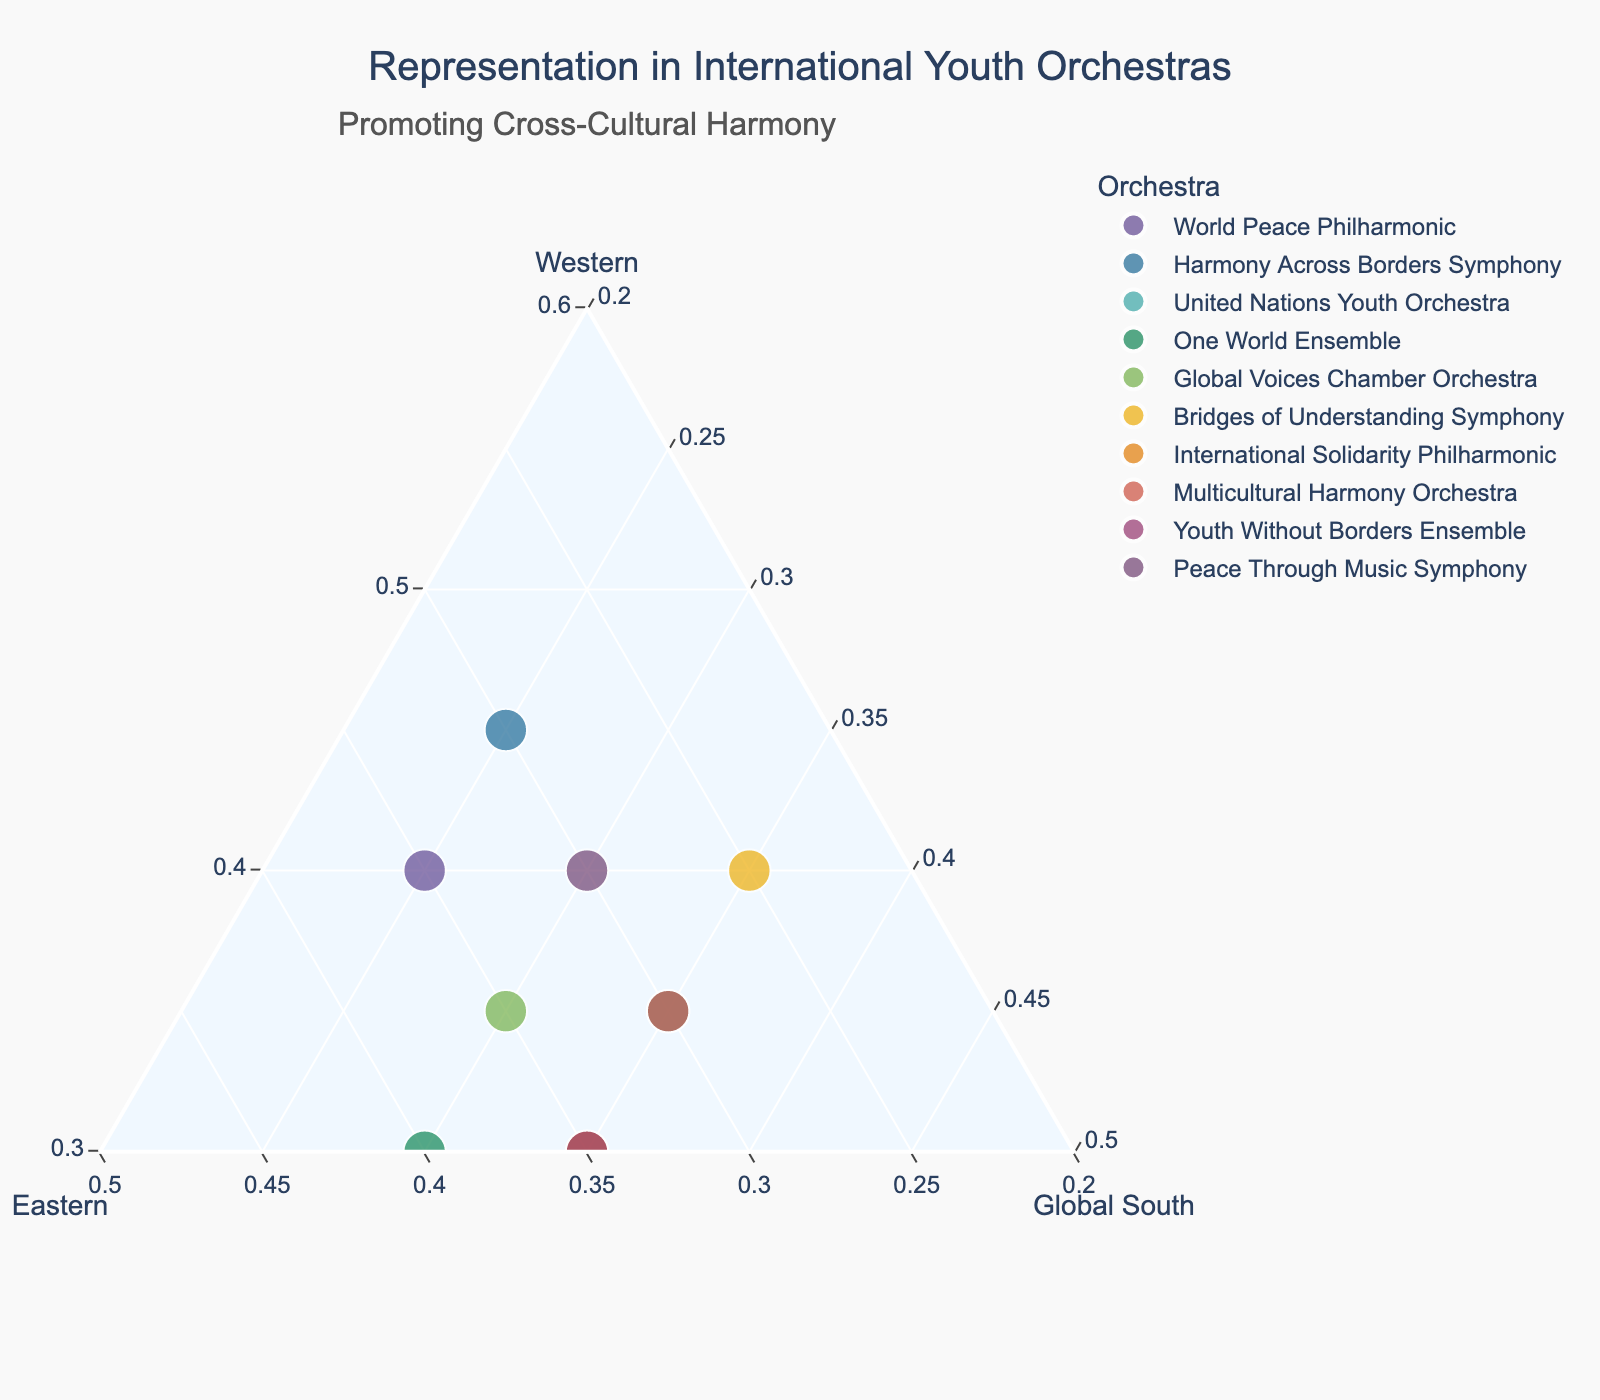Which orchestra places the most emphasis on Western representation? By observing the data points' positions on the ternary plot, we can see which one is closest to the vertex labeled "Western." The Harmony Across Borders Symphony has the highest Western value at 45%.
Answer: Harmony Across Borders Symphony How many orchestras equally represent Western and Eastern nationalities? Look for orchestras where the Western and Eastern values are the same. From the dataset, "World Peace Philharmonic," "Global Voices Chamber Orchestra," "Multicultural Harmony Orchestra," and "Peace Through Music Symphony" all have equal Western and Eastern values.
Answer: 4 Which orchestra has an equal representation of Eastern and Global South nationalities? Check for data points where the values for Eastern and Global South representation are the same. "Youth Without Borders Ensemble" and "International Solidarity Philharmonic" both have 35% for Eastern and Global South.
Answer: Youth Without Borders Ensemble, International Solidarity Philharmonic Is there any orchestra that has a higher representation of Global South than Western? Compare the values for Global South and Western for each orchestra. "United Nations Youth Orchestra" and "Bridges of Understanding Symphony" have higher Global South representation than Western.
Answer: United Nations Youth Orchestra, Bridges of Understanding Symphony What is the median value of Western representation among the orchestras? Arrange the Western representation values in ascending order - 30, 30, 30, 30, 35, 35, 35, 40, 40, 45. The middle values are the 5th and 6th, both 35. Therefore, the median is (35 + 35)/2 = 35.
Answer: 35 Which orchestras have an exactly equal distribution among all three nationalities? Look for data points where the Western, Eastern, and Global South percentages are all equal. None of the orchestras in the dataset meet this criterion of having exactly 33.33% across all three categories.
Answer: None What is the average Global South representation across all orchestras? Sum all the Global South values and divide by the number of orchestras: (25 + 25 + 35 + 30 + 30 + 35 + 35 + 35 + 35 + 30)/10. This gives an average of 31.5%.
Answer: 31.5 Which orchestra lies at the intersection of maximum Eastern and Global South representation? Identify the data point closest to the Eastern and Global South vertices simultaneously. "One World Ensemble" and "Youth Without Borders Ensemble" both have relatively high values for both Eastern and Global South representation at 40% and 35%, respectively.
Answer: One World Ensemble, Youth Without Borders Ensemble 